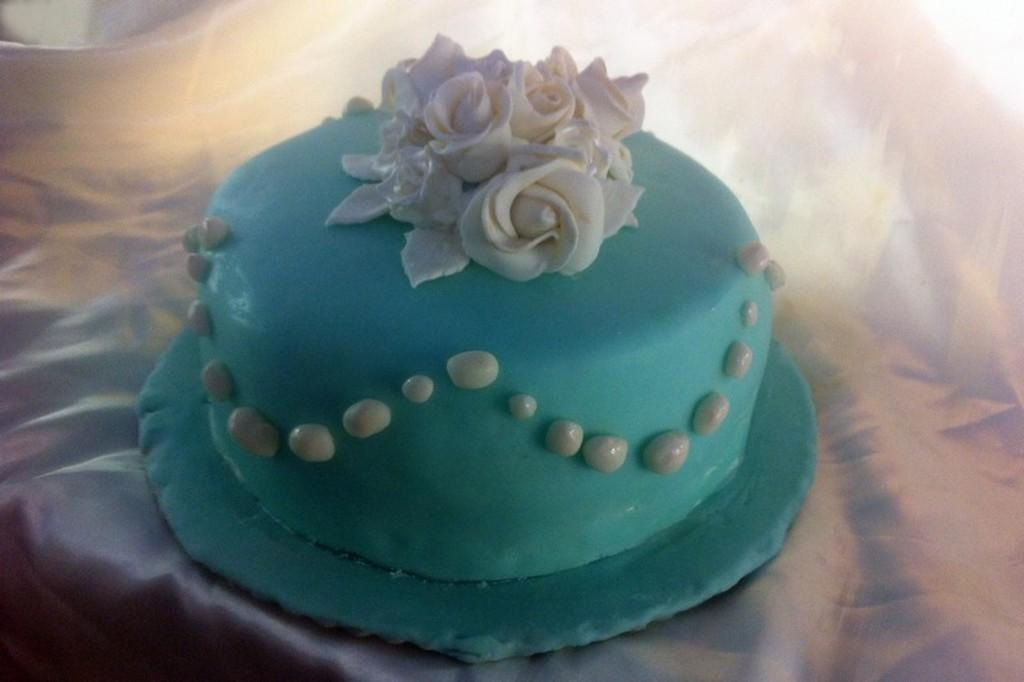What type of furniture is present in the image? There is a table in the image. How is the table decorated or covered? The table is covered with a white cloth. What is placed on the table in the image? There is a cake on the table. How does the cake provide comfort to the people in the image? The image does not show any people, and the cake's purpose is not to provide comfort. 